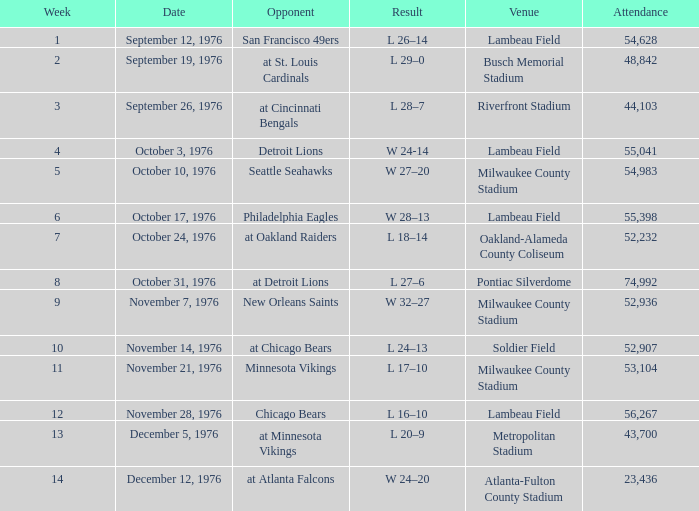What is the lowest week number where they played against the Detroit Lions? 4.0. 